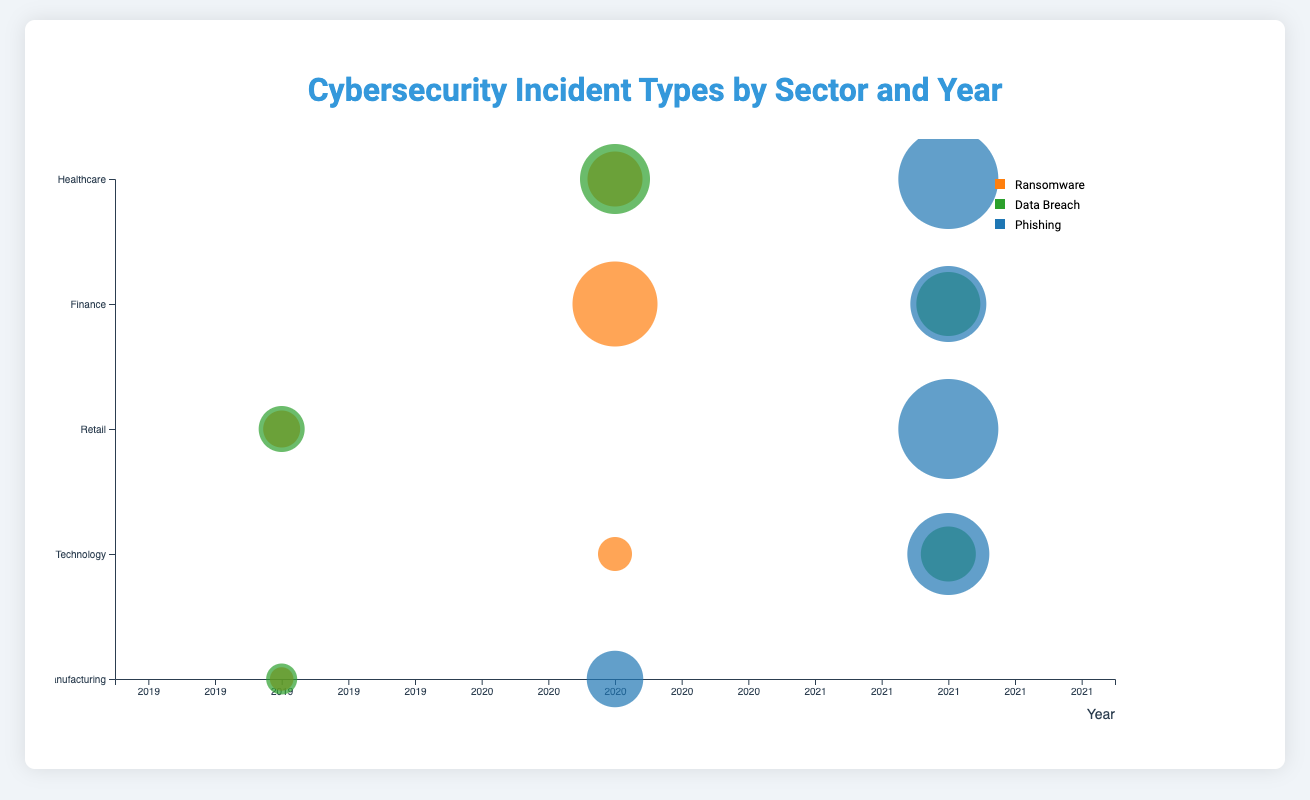What are the sectors shown on the Y-axis? The Y-axis lists all the sectors for which data is provided in the bubble chart. These sectors are shown from top to bottom.
Answer: Manufacturing, Technology, Retail, Finance, Healthcare Which year had the highest number of phishing incidents in the Healthcare sector? To find this, observe the Healthcare row and look for the largest blue bubble, which represents phishing incidents. The largest bubble in the Healthcare row is in 2021.
Answer: 2021 How many incidents of Data Breach were reported in the Retail sector in 2019? Look at the Retail row and find the green bubble for the year 2019. The tooltip indicates 120 incidents.
Answer: 120 Which incident type appears to have the highest incident count in the Technology sector in 2021? Check the Technology row for the year 2021, and look for the largest bubble. The largest bubble for that year in the Technology sector is blue, representing phishing.
Answer: Phishing Compare the number of ransomware incidents in the Finance sector in 2020 to Data Breach incidents in the same sector in 2021. Which is greater? Look at the Finance row and compare the size of the orange bubble for 2020 (250 incidents) to the green bubble for 2021 (180 incidents). The orange bubble is larger.
Answer: Ransomware in 2020 What's the trend of phishing incidents across all sectors from 2019 to 2021? Look at all the blue bubbles in the chart and observe their sizes and positions over the years. Phishing incidents increased significantly, especially highlighted in Healthcare, Retail, and Technology in 2021.
Answer: Increasing Which incident type had the lowest number of incidents in the Manufacturing sector in 2019? Look at the Manufacturing row for the year 2019 and compare the sizes of bubbles. The smallest bubble is for ransomware, indicating the lowest number of incidents.
Answer: Ransomware Is the number of Data Breach incidents in the Technology sector greater in 2020 or 2021? Look at the Technology row and identify the green bubble sizes for 2020 and 2021. There is no Data Breach bubble in 2020, and in 2021 it is 150 incidents.
Answer: 2021 Calculate the total number of ransomware incidents in the Technology and Retail sectors for the year 2019 and 2020. Add the number of ransomware incidents for Retail in 2019 (90) and Technology in 2020 (80). Sum them up: 90 + 80 = 170.
Answer: 170 